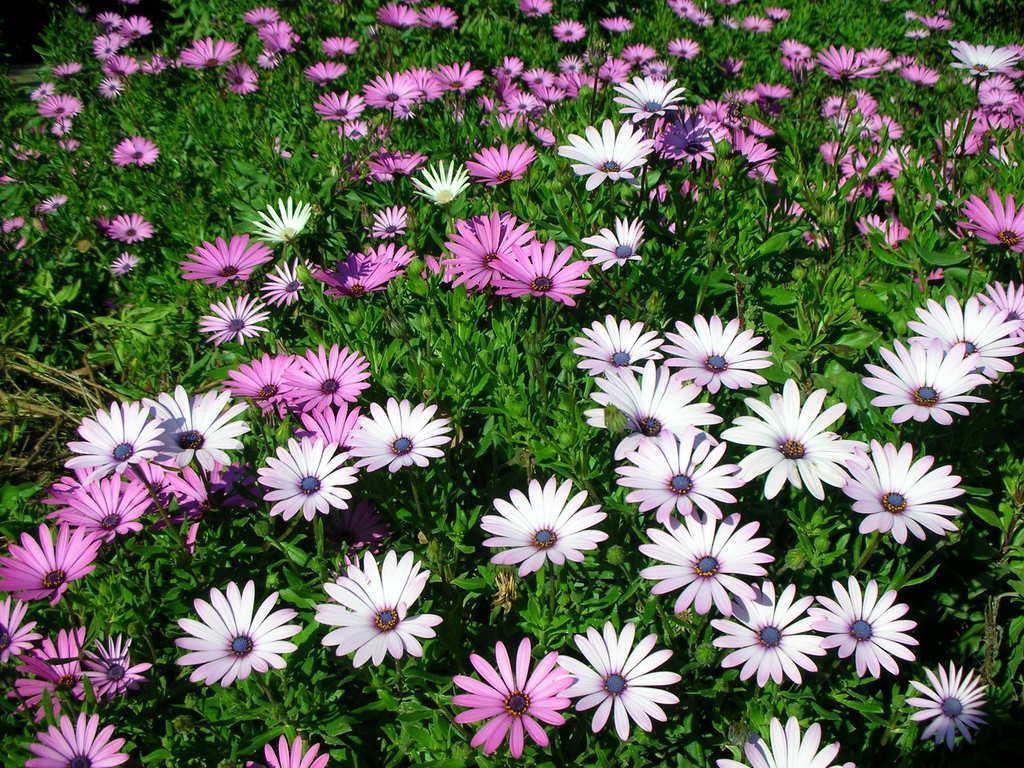Could you give a brief overview of what you see in this image? In this image there are plants and we can see flowers. 